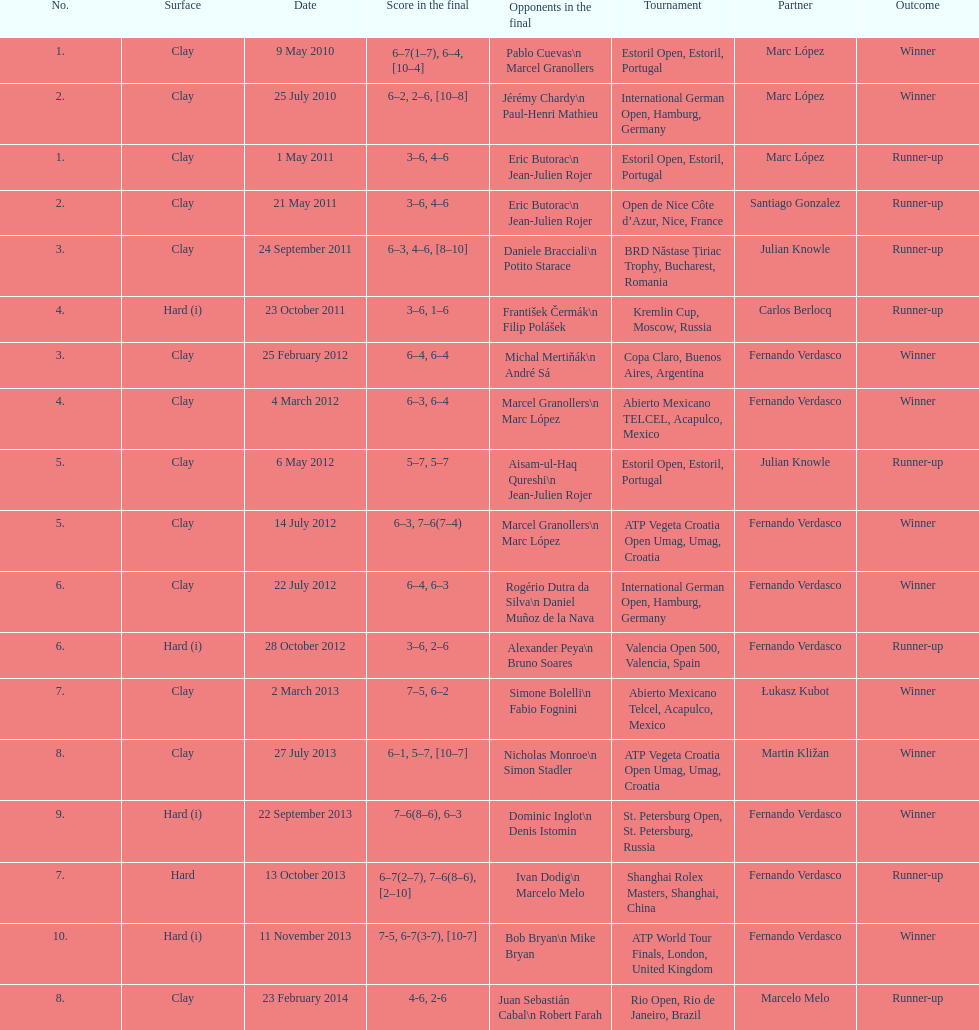Who was this player's next partner after playing with marc lopez in may 2011? Santiago Gonzalez. 